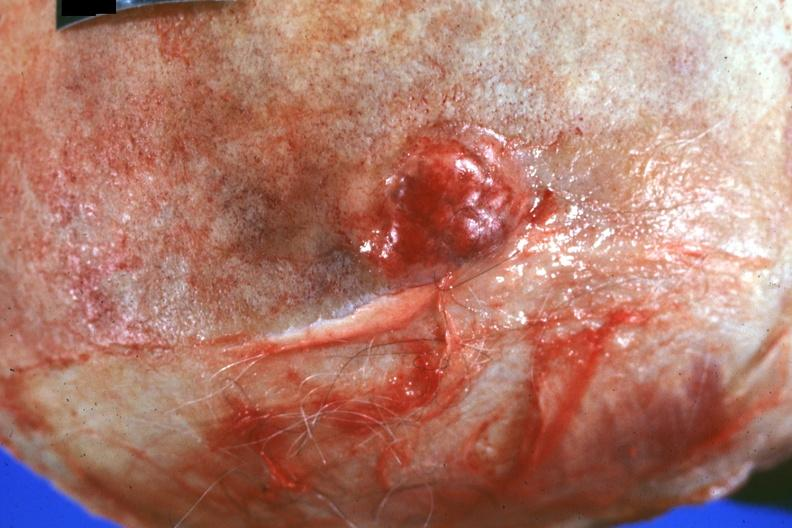what is present?
Answer the question using a single word or phrase. Metastatic carcinoma 